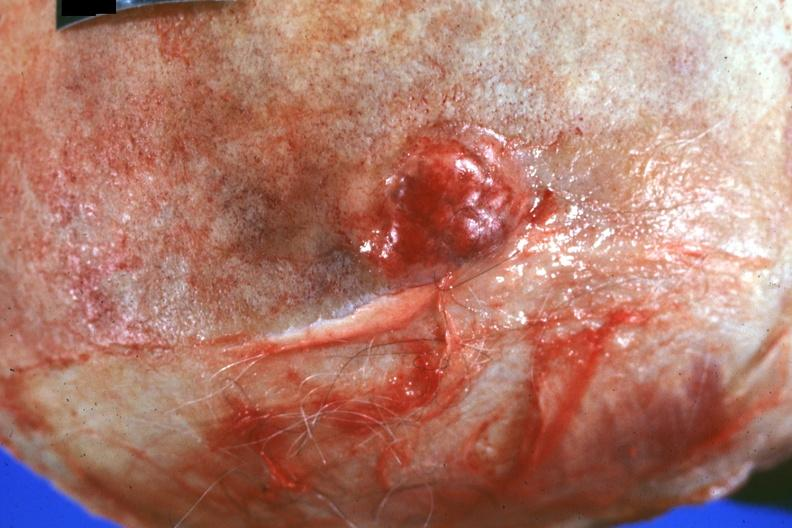what is present?
Answer the question using a single word or phrase. Metastatic carcinoma 